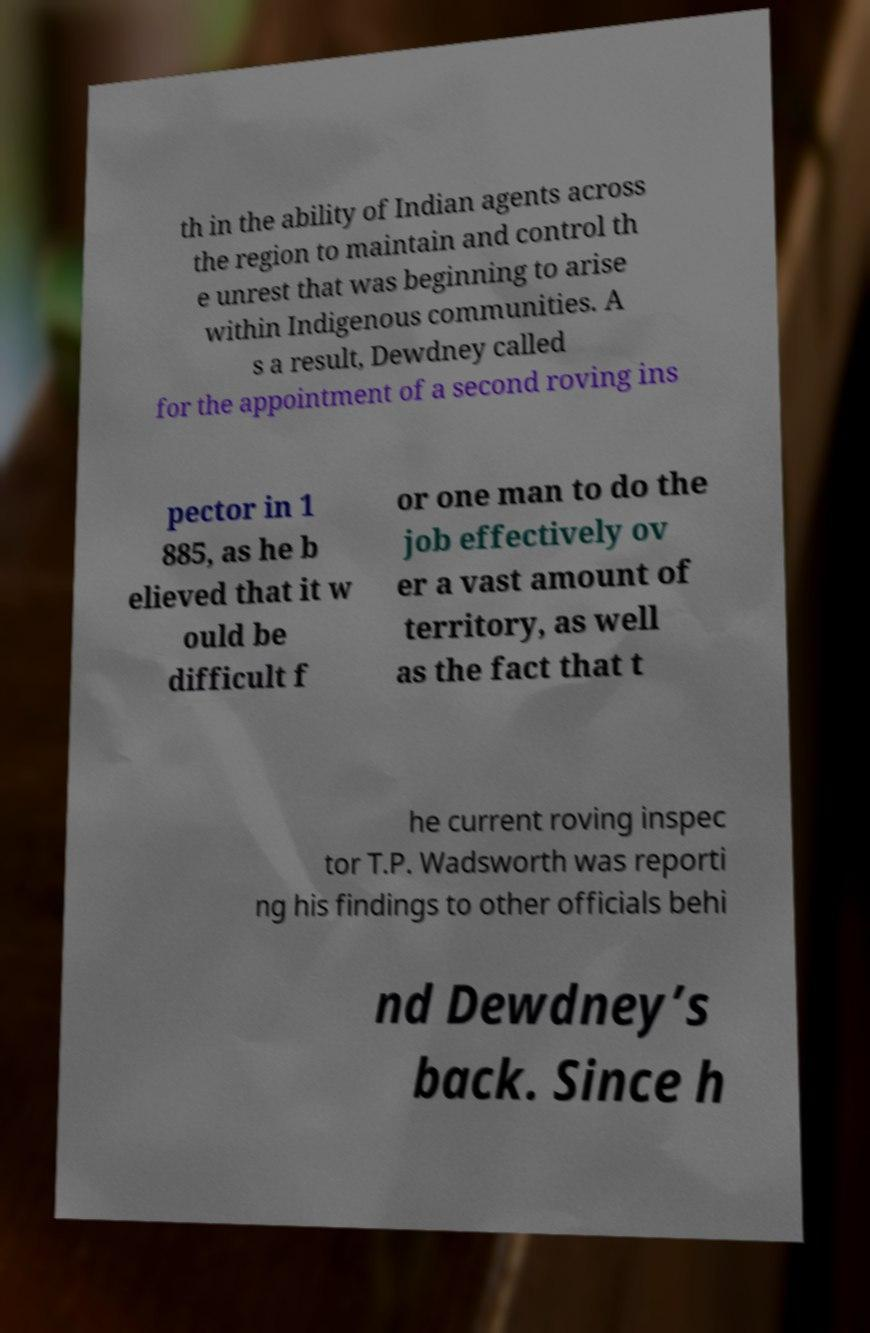Could you assist in decoding the text presented in this image and type it out clearly? th in the ability of Indian agents across the region to maintain and control th e unrest that was beginning to arise within Indigenous communities. A s a result, Dewdney called for the appointment of a second roving ins pector in 1 885, as he b elieved that it w ould be difficult f or one man to do the job effectively ov er a vast amount of territory, as well as the fact that t he current roving inspec tor T.P. Wadsworth was reporti ng his findings to other officials behi nd Dewdney’s back. Since h 